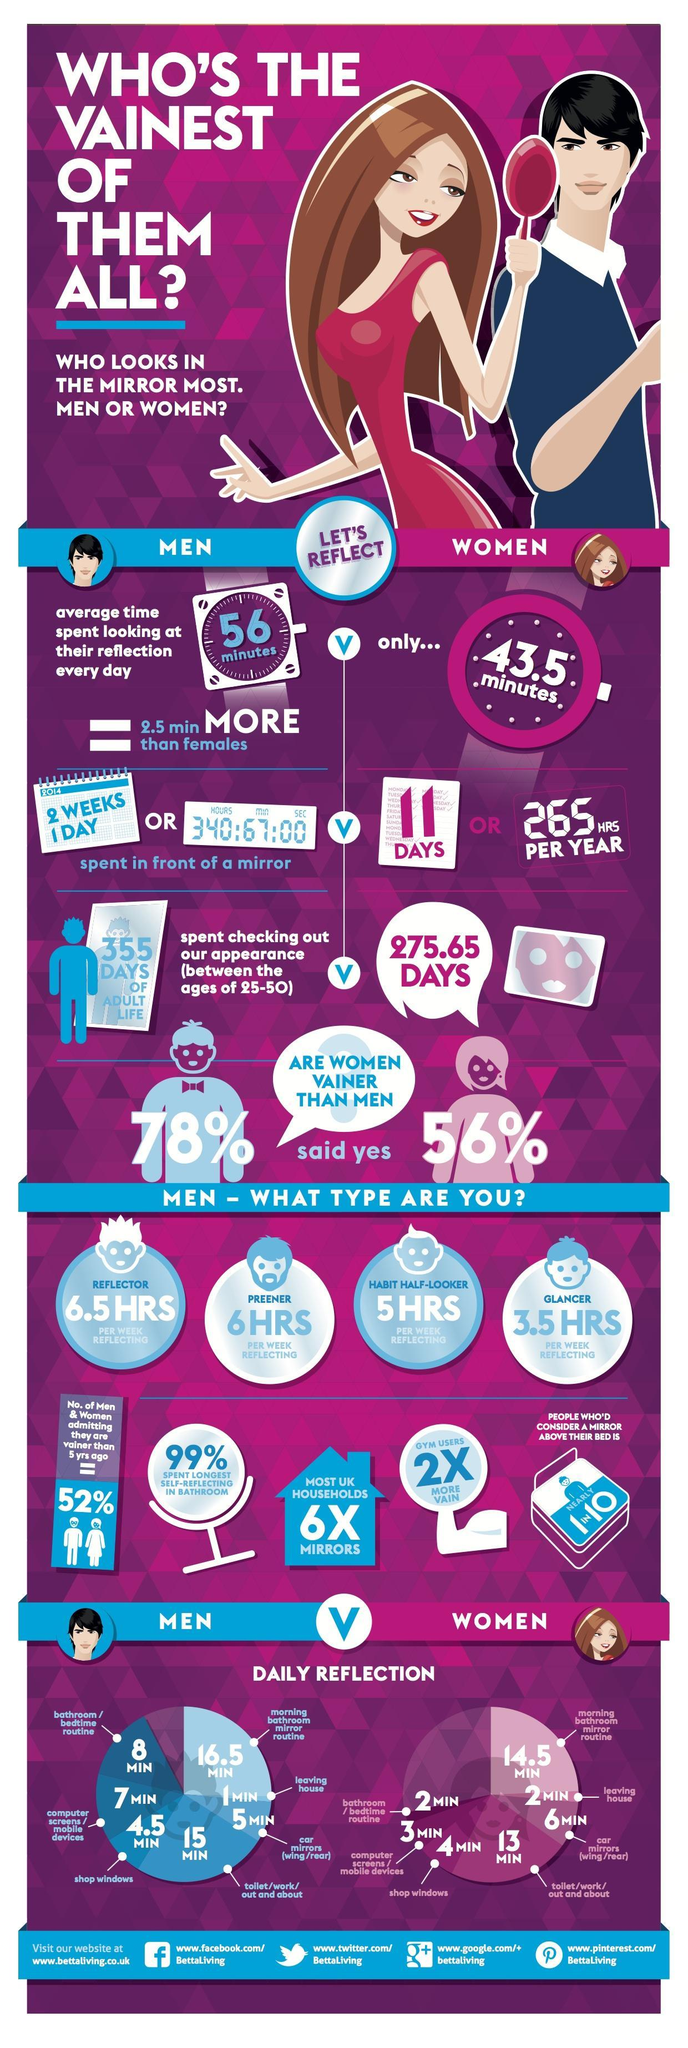What time in minutes does a woman spends in front of the mirror, 56 mins, 43.5 mins, or 2.5 mins?
Answer the question with a short phrase. 43.5 mins What is the time spent by a man looking at his reflection before leaving home, 1 min, 2 min, or 5 min? 1 min What is the time spent by a woman looking at her reflection at the shop windows, 4.5min, 3 min, or 4 min? 4 min What percentage of men believe that women are vainer than men, 56%, 78%, or 99%? 78% How many days does a man spend in front of a mirror, 15 days, 11 days, or 355 days? 15 days How many days of adult life does a woman spend in front of the mirror, 355 days, 265 days, or 275.65 days? 275.65 days Who spends the least amount of time per week in front of the mirror, reflector, preener, habit half-looker, or glancer? glancer 